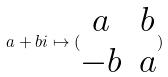Convert formula to latex. <formula><loc_0><loc_0><loc_500><loc_500>a + b i \mapsto ( \begin{matrix} a & b \\ - b & a \end{matrix} )</formula> 